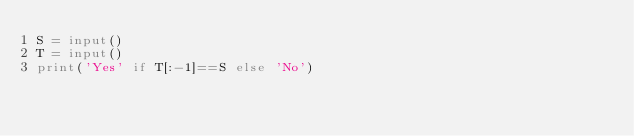<code> <loc_0><loc_0><loc_500><loc_500><_Python_>S = input()
T = input()
print('Yes' if T[:-1]==S else 'No')</code> 